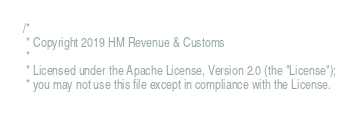<code> <loc_0><loc_0><loc_500><loc_500><_Scala_>/*
 * Copyright 2019 HM Revenue & Customs
 *
 * Licensed under the Apache License, Version 2.0 (the "License");
 * you may not use this file except in compliance with the License.</code> 